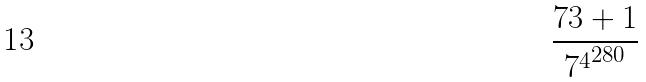Convert formula to latex. <formula><loc_0><loc_0><loc_500><loc_500>\frac { 7 3 + 1 } { { 7 ^ { 4 } } ^ { 2 8 0 } }</formula> 